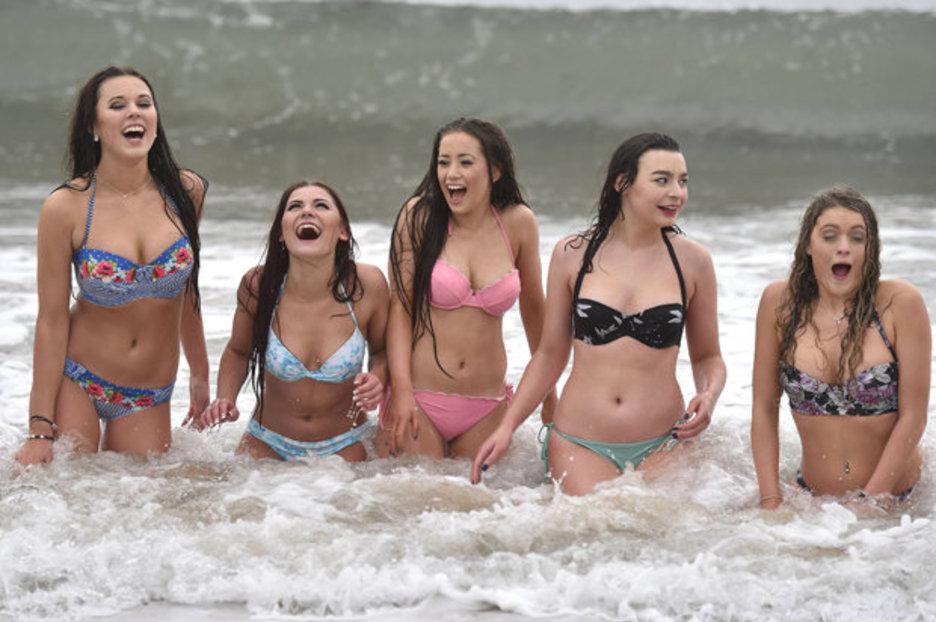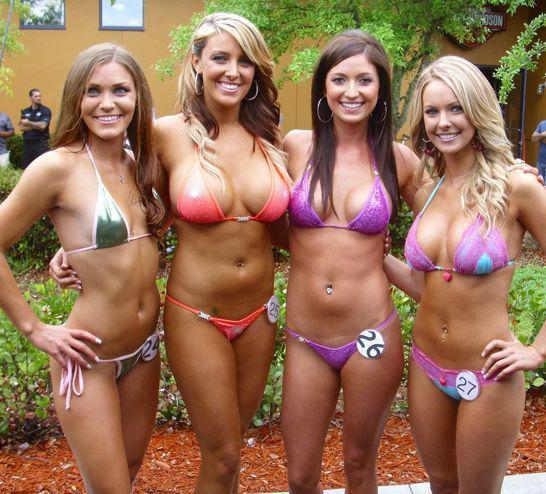The first image is the image on the left, the second image is the image on the right. Analyze the images presented: Is the assertion "One girl has her body turned forward and the rest have their rears to the camera in one image." valid? Answer yes or no. No. The first image is the image on the left, the second image is the image on the right. Evaluate the accuracy of this statement regarding the images: "In at least one image there is a total of five women in bikinis standing in a row.". Is it true? Answer yes or no. Yes. 